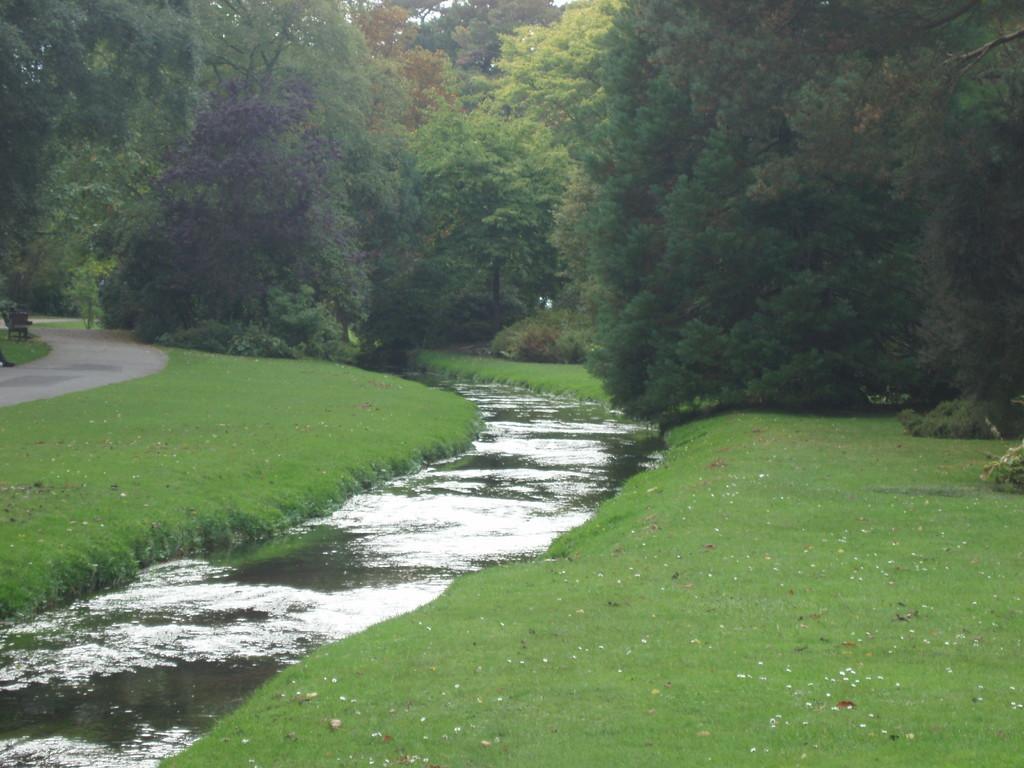Describe this image in one or two sentences. In the center of the image we can see a canal. In the background there are trees. On the left there is a walkway. At the bottom we can see grass. 